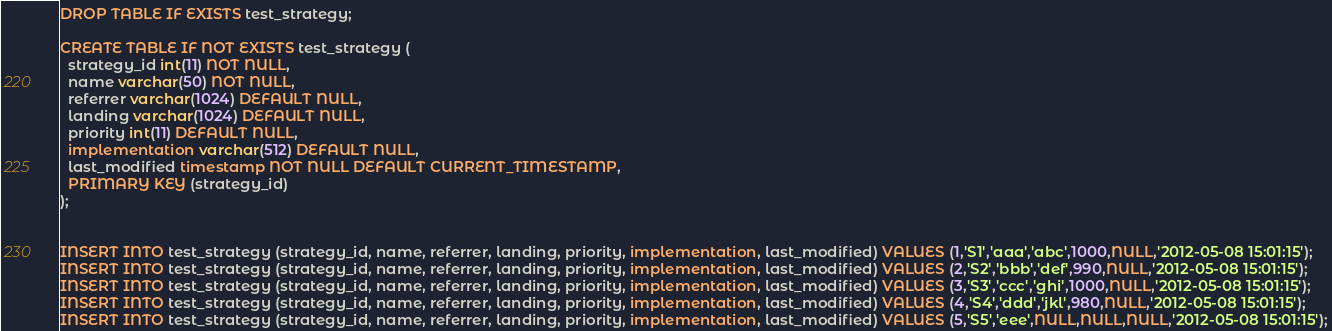<code> <loc_0><loc_0><loc_500><loc_500><_SQL_>DROP TABLE IF EXISTS test_strategy;

CREATE TABLE IF NOT EXISTS test_strategy (
  strategy_id int(11) NOT NULL,
  name varchar(50) NOT NULL,
  referrer varchar(1024) DEFAULT NULL,
  landing varchar(1024) DEFAULT NULL,
  priority int(11) DEFAULT NULL,
  implementation varchar(512) DEFAULT NULL,
  last_modified timestamp NOT NULL DEFAULT CURRENT_TIMESTAMP,
  PRIMARY KEY (strategy_id)
);


INSERT INTO test_strategy (strategy_id, name, referrer, landing, priority, implementation, last_modified) VALUES (1,'S1','aaa','abc',1000,NULL,'2012-05-08 15:01:15');
INSERT INTO test_strategy (strategy_id, name, referrer, landing, priority, implementation, last_modified) VALUES (2,'S2','bbb','def',990,NULL,'2012-05-08 15:01:15');
INSERT INTO test_strategy (strategy_id, name, referrer, landing, priority, implementation, last_modified) VALUES (3,'S3','ccc','ghi',1000,NULL,'2012-05-08 15:01:15');
INSERT INTO test_strategy (strategy_id, name, referrer, landing, priority, implementation, last_modified) VALUES (4,'S4','ddd','jkl',980,NULL,'2012-05-08 15:01:15');
INSERT INTO test_strategy (strategy_id, name, referrer, landing, priority, implementation, last_modified) VALUES (5,'S5','eee',NULL,NULL,NULL,'2012-05-08 15:01:15');


</code> 